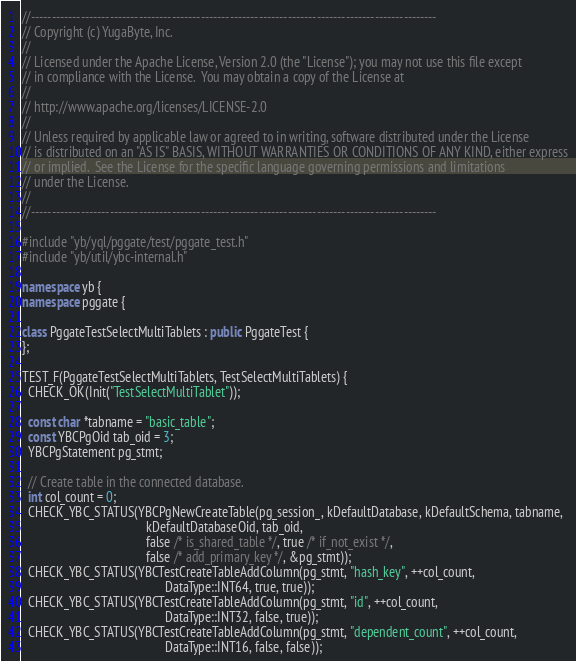<code> <loc_0><loc_0><loc_500><loc_500><_C++_>//--------------------------------------------------------------------------------------------------
// Copyright (c) YugaByte, Inc.
//
// Licensed under the Apache License, Version 2.0 (the "License"); you may not use this file except
// in compliance with the License.  You may obtain a copy of the License at
//
// http://www.apache.org/licenses/LICENSE-2.0
//
// Unless required by applicable law or agreed to in writing, software distributed under the License
// is distributed on an "AS IS" BASIS, WITHOUT WARRANTIES OR CONDITIONS OF ANY KIND, either express
// or implied.  See the License for the specific language governing permissions and limitations
// under the License.
//
//--------------------------------------------------------------------------------------------------

#include "yb/yql/pggate/test/pggate_test.h"
#include "yb/util/ybc-internal.h"

namespace yb {
namespace pggate {

class PggateTestSelectMultiTablets : public PggateTest {
};

TEST_F(PggateTestSelectMultiTablets, TestSelectMultiTablets) {
  CHECK_OK(Init("TestSelectMultiTablet"));

  const char *tabname = "basic_table";
  const YBCPgOid tab_oid = 3;
  YBCPgStatement pg_stmt;

  // Create table in the connected database.
  int col_count = 0;
  CHECK_YBC_STATUS(YBCPgNewCreateTable(pg_session_, kDefaultDatabase, kDefaultSchema, tabname,
                                       kDefaultDatabaseOid, tab_oid,
                                       false /* is_shared_table */, true /* if_not_exist */,
                                       false /* add_primary_key */, &pg_stmt));
  CHECK_YBC_STATUS(YBCTestCreateTableAddColumn(pg_stmt, "hash_key", ++col_count,
                                             DataType::INT64, true, true));
  CHECK_YBC_STATUS(YBCTestCreateTableAddColumn(pg_stmt, "id", ++col_count,
                                             DataType::INT32, false, true));
  CHECK_YBC_STATUS(YBCTestCreateTableAddColumn(pg_stmt, "dependent_count", ++col_count,
                                             DataType::INT16, false, false));</code> 